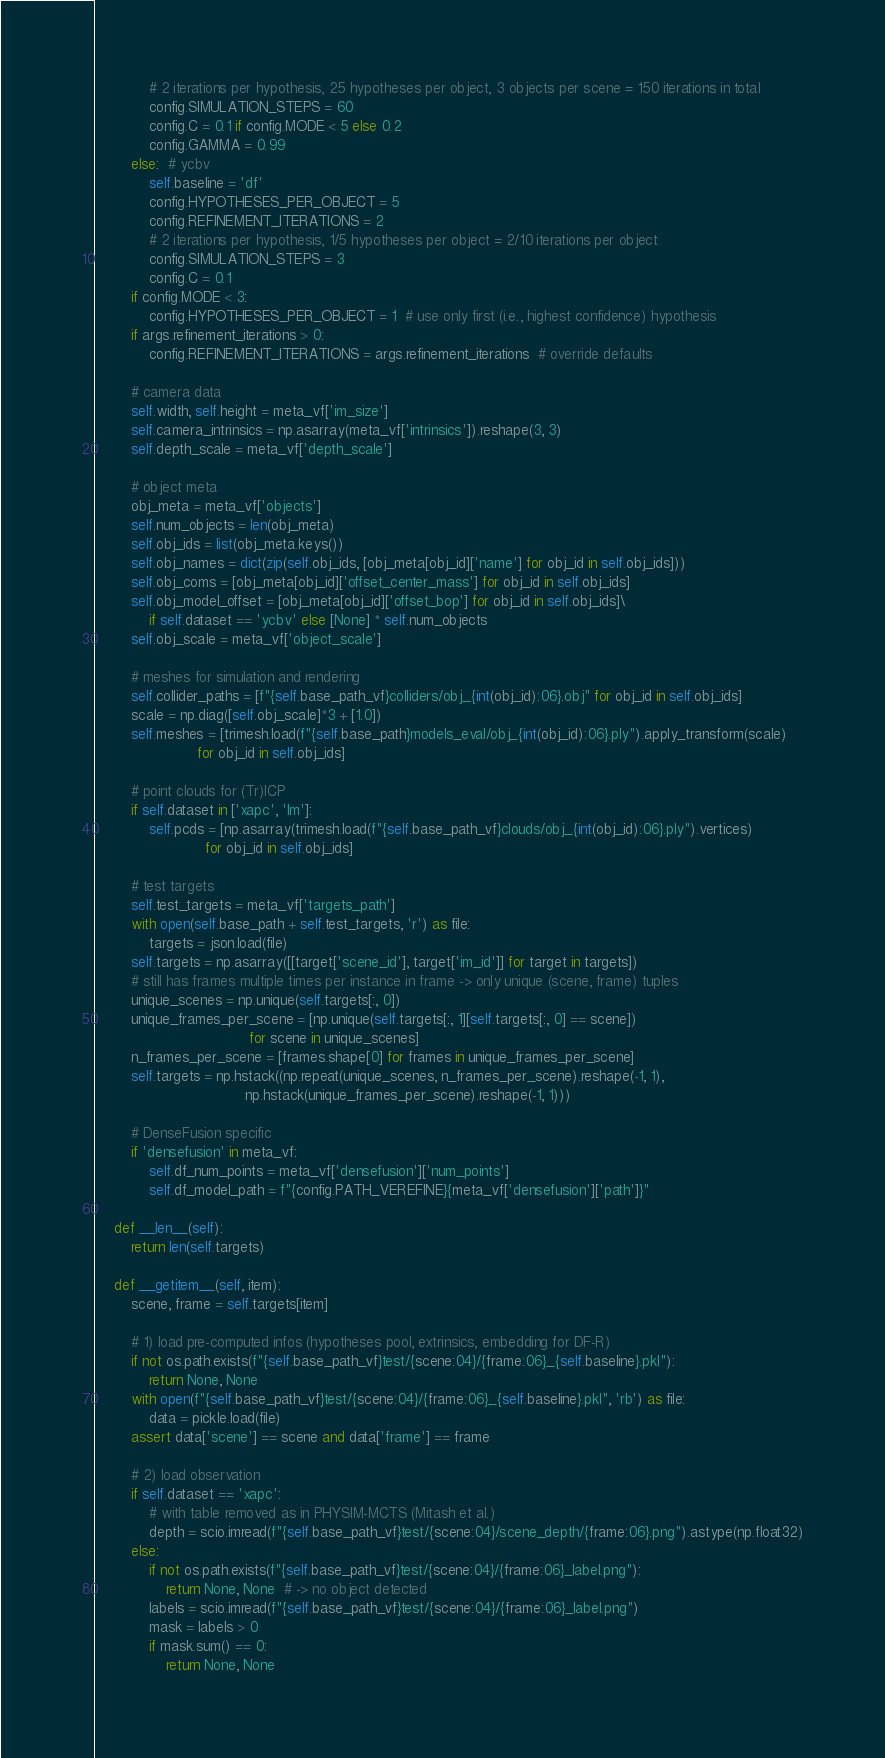<code> <loc_0><loc_0><loc_500><loc_500><_Python_>            # 2 iterations per hypothesis, 25 hypotheses per object, 3 objects per scene = 150 iterations in total
            config.SIMULATION_STEPS = 60
            config.C = 0.1 if config.MODE < 5 else 0.2
            config.GAMMA = 0.99
        else:  # ycbv
            self.baseline = 'df'
            config.HYPOTHESES_PER_OBJECT = 5
            config.REFINEMENT_ITERATIONS = 2
            # 2 iterations per hypothesis, 1/5 hypotheses per object = 2/10 iterations per object
            config.SIMULATION_STEPS = 3
            config.C = 0.1
        if config.MODE < 3:
            config.HYPOTHESES_PER_OBJECT = 1  # use only first (i.e., highest confidence) hypothesis
        if args.refinement_iterations > 0:
            config.REFINEMENT_ITERATIONS = args.refinement_iterations  # override defaults

        # camera data
        self.width, self.height = meta_vf['im_size']
        self.camera_intrinsics = np.asarray(meta_vf['intrinsics']).reshape(3, 3)
        self.depth_scale = meta_vf['depth_scale']

        # object meta
        obj_meta = meta_vf['objects']
        self.num_objects = len(obj_meta)
        self.obj_ids = list(obj_meta.keys())
        self.obj_names = dict(zip(self.obj_ids, [obj_meta[obj_id]['name'] for obj_id in self.obj_ids]))
        self.obj_coms = [obj_meta[obj_id]['offset_center_mass'] for obj_id in self.obj_ids]
        self.obj_model_offset = [obj_meta[obj_id]['offset_bop'] for obj_id in self.obj_ids]\
            if self.dataset == 'ycbv' else [None] * self.num_objects
        self.obj_scale = meta_vf['object_scale']

        # meshes for simulation and rendering
        self.collider_paths = [f"{self.base_path_vf}colliders/obj_{int(obj_id):06}.obj" for obj_id in self.obj_ids]
        scale = np.diag([self.obj_scale]*3 + [1.0])
        self.meshes = [trimesh.load(f"{self.base_path}models_eval/obj_{int(obj_id):06}.ply").apply_transform(scale)
                       for obj_id in self.obj_ids]

        # point clouds for (Tr)ICP
        if self.dataset in ['xapc', 'lm']:
            self.pcds = [np.asarray(trimesh.load(f"{self.base_path_vf}clouds/obj_{int(obj_id):06}.ply").vertices)
                         for obj_id in self.obj_ids]

        # test targets
        self.test_targets = meta_vf['targets_path']
        with open(self.base_path + self.test_targets, 'r') as file:
            targets = json.load(file)
        self.targets = np.asarray([[target['scene_id'], target['im_id']] for target in targets])
        # still has frames multiple times per instance in frame -> only unique (scene, frame) tuples
        unique_scenes = np.unique(self.targets[:, 0])
        unique_frames_per_scene = [np.unique(self.targets[:, 1][self.targets[:, 0] == scene])
                                   for scene in unique_scenes]
        n_frames_per_scene = [frames.shape[0] for frames in unique_frames_per_scene]
        self.targets = np.hstack((np.repeat(unique_scenes, n_frames_per_scene).reshape(-1, 1),
                                  np.hstack(unique_frames_per_scene).reshape(-1, 1)))

        # DenseFusion specific
        if 'densefusion' in meta_vf:
            self.df_num_points = meta_vf['densefusion']['num_points']
            self.df_model_path = f"{config.PATH_VEREFINE}{meta_vf['densefusion']['path']}"

    def __len__(self):
        return len(self.targets)

    def __getitem__(self, item):
        scene, frame = self.targets[item]

        # 1) load pre-computed infos (hypotheses pool, extrinsics, embedding for DF-R)
        if not os.path.exists(f"{self.base_path_vf}test/{scene:04}/{frame:06}_{self.baseline}.pkl"):
            return None, None
        with open(f"{self.base_path_vf}test/{scene:04}/{frame:06}_{self.baseline}.pkl", 'rb') as file:
            data = pickle.load(file)
        assert data['scene'] == scene and data['frame'] == frame

        # 2) load observation
        if self.dataset == 'xapc':
            # with table removed as in PHYSIM-MCTS (Mitash et al.)
            depth = scio.imread(f"{self.base_path_vf}test/{scene:04}/scene_depth/{frame:06}.png").astype(np.float32)
        else:
            if not os.path.exists(f"{self.base_path_vf}test/{scene:04}/{frame:06}_label.png"):
                return None, None  # -> no object detected
            labels = scio.imread(f"{self.base_path_vf}test/{scene:04}/{frame:06}_label.png")
            mask = labels > 0
            if mask.sum() == 0:
                return None, None
</code> 